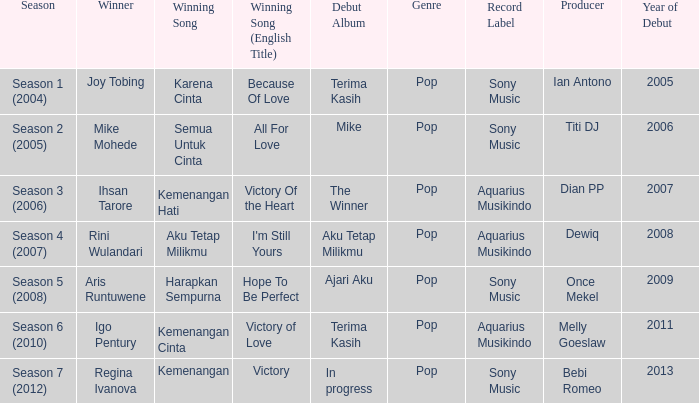Which English winning song had the winner aris runtuwene? Hope To Be Perfect. 